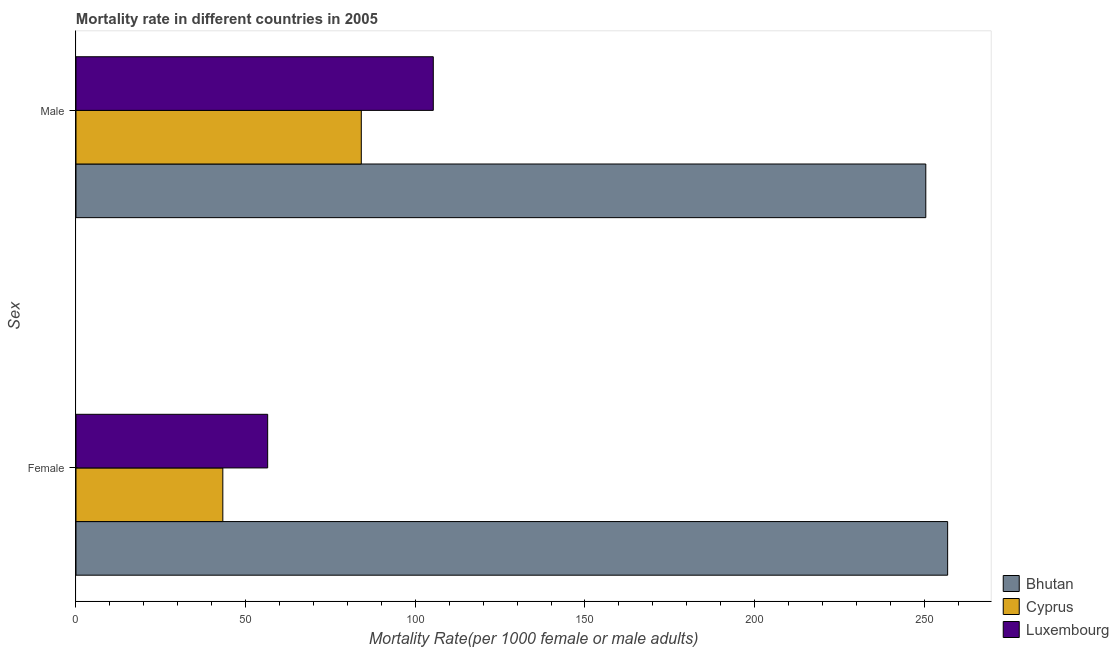How many groups of bars are there?
Your answer should be compact. 2. How many bars are there on the 2nd tick from the bottom?
Your response must be concise. 3. What is the male mortality rate in Bhutan?
Give a very brief answer. 250.45. Across all countries, what is the maximum female mortality rate?
Your answer should be very brief. 256.89. Across all countries, what is the minimum male mortality rate?
Provide a succinct answer. 84.09. In which country was the female mortality rate maximum?
Your answer should be very brief. Bhutan. In which country was the male mortality rate minimum?
Keep it short and to the point. Cyprus. What is the total male mortality rate in the graph?
Make the answer very short. 439.84. What is the difference between the female mortality rate in Luxembourg and that in Bhutan?
Offer a terse response. -200.4. What is the difference between the male mortality rate in Cyprus and the female mortality rate in Bhutan?
Keep it short and to the point. -172.81. What is the average male mortality rate per country?
Offer a terse response. 146.61. What is the difference between the female mortality rate and male mortality rate in Bhutan?
Give a very brief answer. 6.44. In how many countries, is the male mortality rate greater than 30 ?
Provide a short and direct response. 3. What is the ratio of the male mortality rate in Bhutan to that in Cyprus?
Ensure brevity in your answer.  2.98. Is the male mortality rate in Cyprus less than that in Luxembourg?
Offer a terse response. Yes. In how many countries, is the male mortality rate greater than the average male mortality rate taken over all countries?
Provide a short and direct response. 1. What does the 3rd bar from the top in Male represents?
Make the answer very short. Bhutan. What does the 1st bar from the bottom in Female represents?
Provide a succinct answer. Bhutan. How many bars are there?
Ensure brevity in your answer.  6. Are all the bars in the graph horizontal?
Offer a terse response. Yes. What is the difference between two consecutive major ticks on the X-axis?
Offer a very short reply. 50. Does the graph contain any zero values?
Provide a succinct answer. No. What is the title of the graph?
Your answer should be very brief. Mortality rate in different countries in 2005. What is the label or title of the X-axis?
Offer a very short reply. Mortality Rate(per 1000 female or male adults). What is the label or title of the Y-axis?
Offer a terse response. Sex. What is the Mortality Rate(per 1000 female or male adults) of Bhutan in Female?
Your answer should be very brief. 256.89. What is the Mortality Rate(per 1000 female or male adults) in Cyprus in Female?
Make the answer very short. 43.28. What is the Mortality Rate(per 1000 female or male adults) in Luxembourg in Female?
Ensure brevity in your answer.  56.49. What is the Mortality Rate(per 1000 female or male adults) of Bhutan in Male?
Provide a succinct answer. 250.45. What is the Mortality Rate(per 1000 female or male adults) in Cyprus in Male?
Keep it short and to the point. 84.09. What is the Mortality Rate(per 1000 female or male adults) in Luxembourg in Male?
Your answer should be very brief. 105.31. Across all Sex, what is the maximum Mortality Rate(per 1000 female or male adults) in Bhutan?
Make the answer very short. 256.89. Across all Sex, what is the maximum Mortality Rate(per 1000 female or male adults) of Cyprus?
Your answer should be very brief. 84.09. Across all Sex, what is the maximum Mortality Rate(per 1000 female or male adults) in Luxembourg?
Make the answer very short. 105.31. Across all Sex, what is the minimum Mortality Rate(per 1000 female or male adults) of Bhutan?
Provide a short and direct response. 250.45. Across all Sex, what is the minimum Mortality Rate(per 1000 female or male adults) of Cyprus?
Provide a short and direct response. 43.28. Across all Sex, what is the minimum Mortality Rate(per 1000 female or male adults) of Luxembourg?
Your answer should be compact. 56.49. What is the total Mortality Rate(per 1000 female or male adults) in Bhutan in the graph?
Keep it short and to the point. 507.35. What is the total Mortality Rate(per 1000 female or male adults) of Cyprus in the graph?
Provide a short and direct response. 127.36. What is the total Mortality Rate(per 1000 female or male adults) of Luxembourg in the graph?
Your answer should be very brief. 161.8. What is the difference between the Mortality Rate(per 1000 female or male adults) in Bhutan in Female and that in Male?
Ensure brevity in your answer.  6.44. What is the difference between the Mortality Rate(per 1000 female or male adults) in Cyprus in Female and that in Male?
Give a very brief answer. -40.81. What is the difference between the Mortality Rate(per 1000 female or male adults) of Luxembourg in Female and that in Male?
Offer a terse response. -48.81. What is the difference between the Mortality Rate(per 1000 female or male adults) of Bhutan in Female and the Mortality Rate(per 1000 female or male adults) of Cyprus in Male?
Offer a terse response. 172.81. What is the difference between the Mortality Rate(per 1000 female or male adults) in Bhutan in Female and the Mortality Rate(per 1000 female or male adults) in Luxembourg in Male?
Your answer should be very brief. 151.59. What is the difference between the Mortality Rate(per 1000 female or male adults) of Cyprus in Female and the Mortality Rate(per 1000 female or male adults) of Luxembourg in Male?
Your answer should be compact. -62.03. What is the average Mortality Rate(per 1000 female or male adults) in Bhutan per Sex?
Give a very brief answer. 253.67. What is the average Mortality Rate(per 1000 female or male adults) of Cyprus per Sex?
Make the answer very short. 63.68. What is the average Mortality Rate(per 1000 female or male adults) in Luxembourg per Sex?
Provide a succinct answer. 80.9. What is the difference between the Mortality Rate(per 1000 female or male adults) in Bhutan and Mortality Rate(per 1000 female or male adults) in Cyprus in Female?
Offer a terse response. 213.62. What is the difference between the Mortality Rate(per 1000 female or male adults) of Bhutan and Mortality Rate(per 1000 female or male adults) of Luxembourg in Female?
Your response must be concise. 200.4. What is the difference between the Mortality Rate(per 1000 female or male adults) of Cyprus and Mortality Rate(per 1000 female or male adults) of Luxembourg in Female?
Ensure brevity in your answer.  -13.22. What is the difference between the Mortality Rate(per 1000 female or male adults) in Bhutan and Mortality Rate(per 1000 female or male adults) in Cyprus in Male?
Make the answer very short. 166.37. What is the difference between the Mortality Rate(per 1000 female or male adults) of Bhutan and Mortality Rate(per 1000 female or male adults) of Luxembourg in Male?
Provide a short and direct response. 145.15. What is the difference between the Mortality Rate(per 1000 female or male adults) in Cyprus and Mortality Rate(per 1000 female or male adults) in Luxembourg in Male?
Provide a succinct answer. -21.22. What is the ratio of the Mortality Rate(per 1000 female or male adults) in Bhutan in Female to that in Male?
Your response must be concise. 1.03. What is the ratio of the Mortality Rate(per 1000 female or male adults) of Cyprus in Female to that in Male?
Ensure brevity in your answer.  0.51. What is the ratio of the Mortality Rate(per 1000 female or male adults) in Luxembourg in Female to that in Male?
Provide a short and direct response. 0.54. What is the difference between the highest and the second highest Mortality Rate(per 1000 female or male adults) in Bhutan?
Your answer should be very brief. 6.44. What is the difference between the highest and the second highest Mortality Rate(per 1000 female or male adults) of Cyprus?
Your response must be concise. 40.81. What is the difference between the highest and the second highest Mortality Rate(per 1000 female or male adults) in Luxembourg?
Offer a very short reply. 48.81. What is the difference between the highest and the lowest Mortality Rate(per 1000 female or male adults) of Bhutan?
Your answer should be compact. 6.44. What is the difference between the highest and the lowest Mortality Rate(per 1000 female or male adults) of Cyprus?
Offer a very short reply. 40.81. What is the difference between the highest and the lowest Mortality Rate(per 1000 female or male adults) in Luxembourg?
Offer a very short reply. 48.81. 